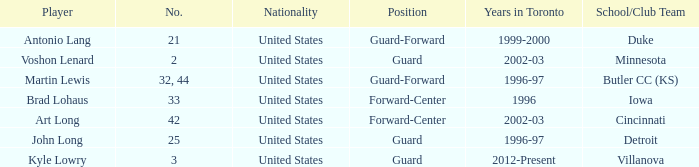How many schools did player number 3 play at? 1.0. 